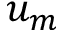<formula> <loc_0><loc_0><loc_500><loc_500>u _ { m }</formula> 